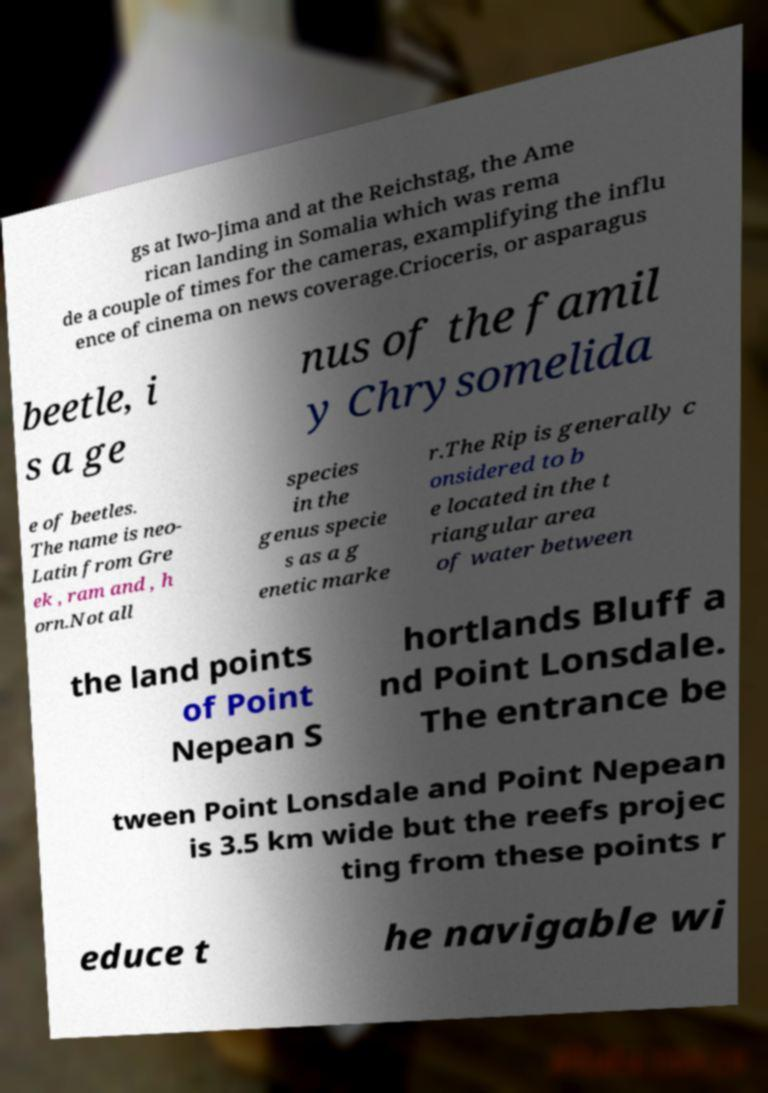Can you read and provide the text displayed in the image?This photo seems to have some interesting text. Can you extract and type it out for me? gs at Iwo-Jima and at the Reichstag, the Ame rican landing in Somalia which was rema de a couple of times for the cameras, examplifying the influ ence of cinema on news coverage.Crioceris, or asparagus beetle, i s a ge nus of the famil y Chrysomelida e of beetles. The name is neo- Latin from Gre ek , ram and , h orn.Not all species in the genus specie s as a g enetic marke r.The Rip is generally c onsidered to b e located in the t riangular area of water between the land points of Point Nepean S hortlands Bluff a nd Point Lonsdale. The entrance be tween Point Lonsdale and Point Nepean is 3.5 km wide but the reefs projec ting from these points r educe t he navigable wi 